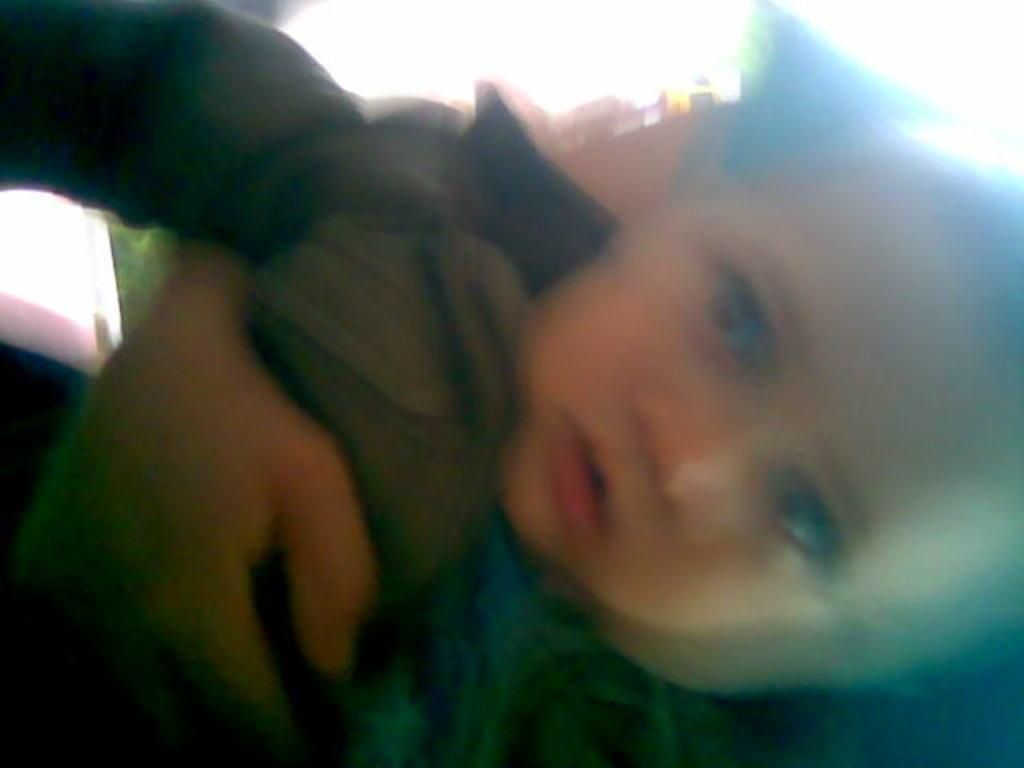What is the main subject of the image? There is a small baby in the image. What is the baby's position in the image? The baby is being held by a person. Can you describe the quality of the image? The image is blurry. What type of celery can be seen in the background of the image? There is no celery present in the image. Is the baby's sister visible in the image? The provided facts do not mention the presence of a sister, so we cannot determine if the baby's sister is visible in the image. 